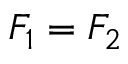<formula> <loc_0><loc_0><loc_500><loc_500>F _ { 1 } = F _ { 2 }</formula> 